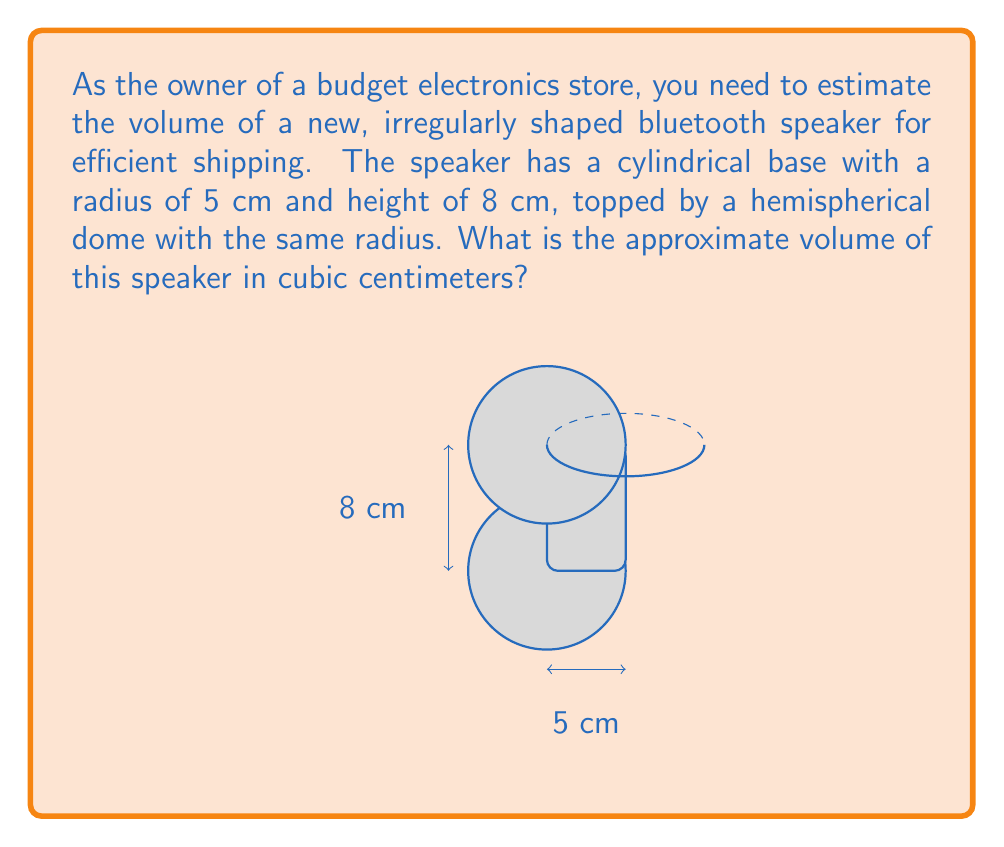What is the answer to this math problem? To estimate the volume of this irregularly shaped speaker, we need to break it down into two parts: a cylinder and a hemisphere. Let's calculate the volume of each part separately and then sum them up.

1. Volume of the cylindrical base:
   The formula for the volume of a cylinder is $V_c = \pi r^2 h$
   Where $r$ is the radius and $h$ is the height
   $V_c = \pi \cdot (5\text{ cm})^2 \cdot 8\text{ cm}$
   $V_c = \pi \cdot 25\text{ cm}^2 \cdot 8\text{ cm} = 200\pi\text{ cm}^3$

2. Volume of the hemispherical dome:
   The formula for the volume of a hemisphere is $V_h = \frac{2}{3}\pi r^3$
   $V_h = \frac{2}{3}\pi \cdot (5\text{ cm})^3$
   $V_h = \frac{2}{3}\pi \cdot 125\text{ cm}^3 = \frac{250}{3}\pi\text{ cm}^3$

3. Total volume:
   $V_{\text{total}} = V_c + V_h$
   $V_{\text{total}} = 200\pi\text{ cm}^3 + \frac{250}{3}\pi\text{ cm}^3$
   $V_{\text{total}} = (200 + \frac{250}{3})\pi\text{ cm}^3$
   $V_{\text{total}} = \frac{850}{3}\pi\text{ cm}^3$

4. Simplifying:
   $\frac{850}{3}\pi\text{ cm}^3 \approx 890.12\text{ cm}^3$

Therefore, the approximate volume of the speaker is 890 cubic centimeters (rounded to the nearest whole number).
Answer: 890 cm³ 